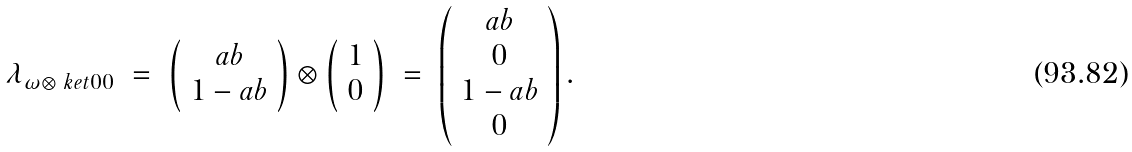<formula> <loc_0><loc_0><loc_500><loc_500>\begin{array} { r c c c l } \lambda _ { \omega \otimes \ k e t { 0 0 } } & = & \left ( \begin{array} { c } a b \\ 1 - a b \end{array} \right ) \otimes \left ( \begin{array} { c } 1 \\ 0 \end{array} \right ) & = & \left ( \begin{array} { c } a b \\ 0 \\ 1 - a b \\ 0 \end{array} \right ) . \\ \end{array}</formula> 